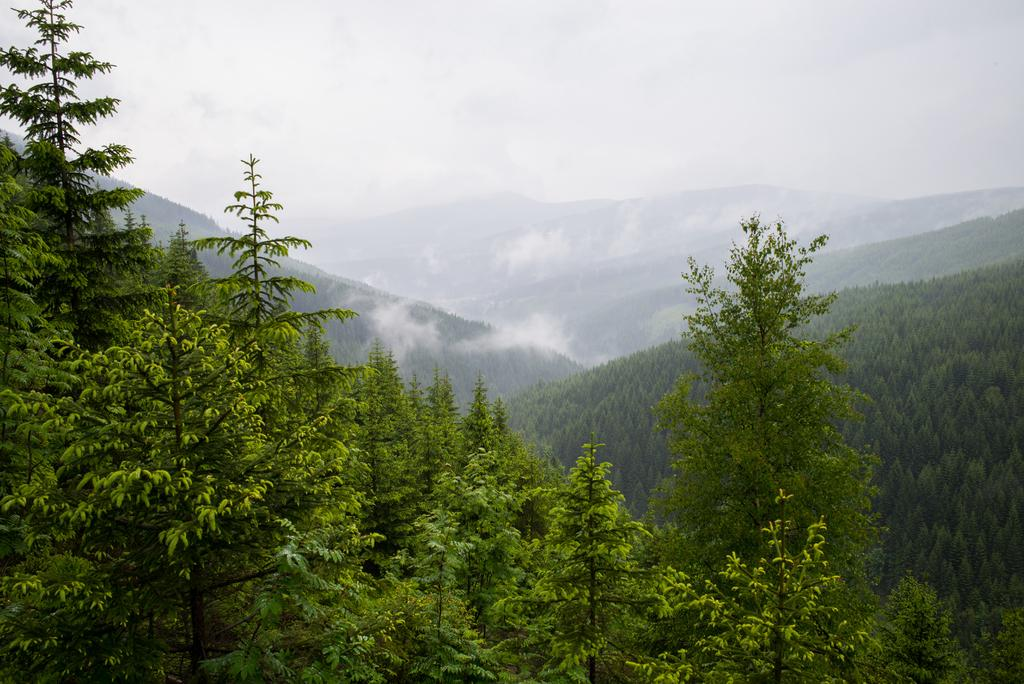Where was the image taken? The image was taken outdoors. What can be seen in the sky in the image? There is a sky with clouds visible in the image. What type of landscape is visible at the bottom of the image? There are hills with many trees and plants at the bottom of the image. How many veins can be seen in the boot in the image? There is no boot or veins present in the image. 